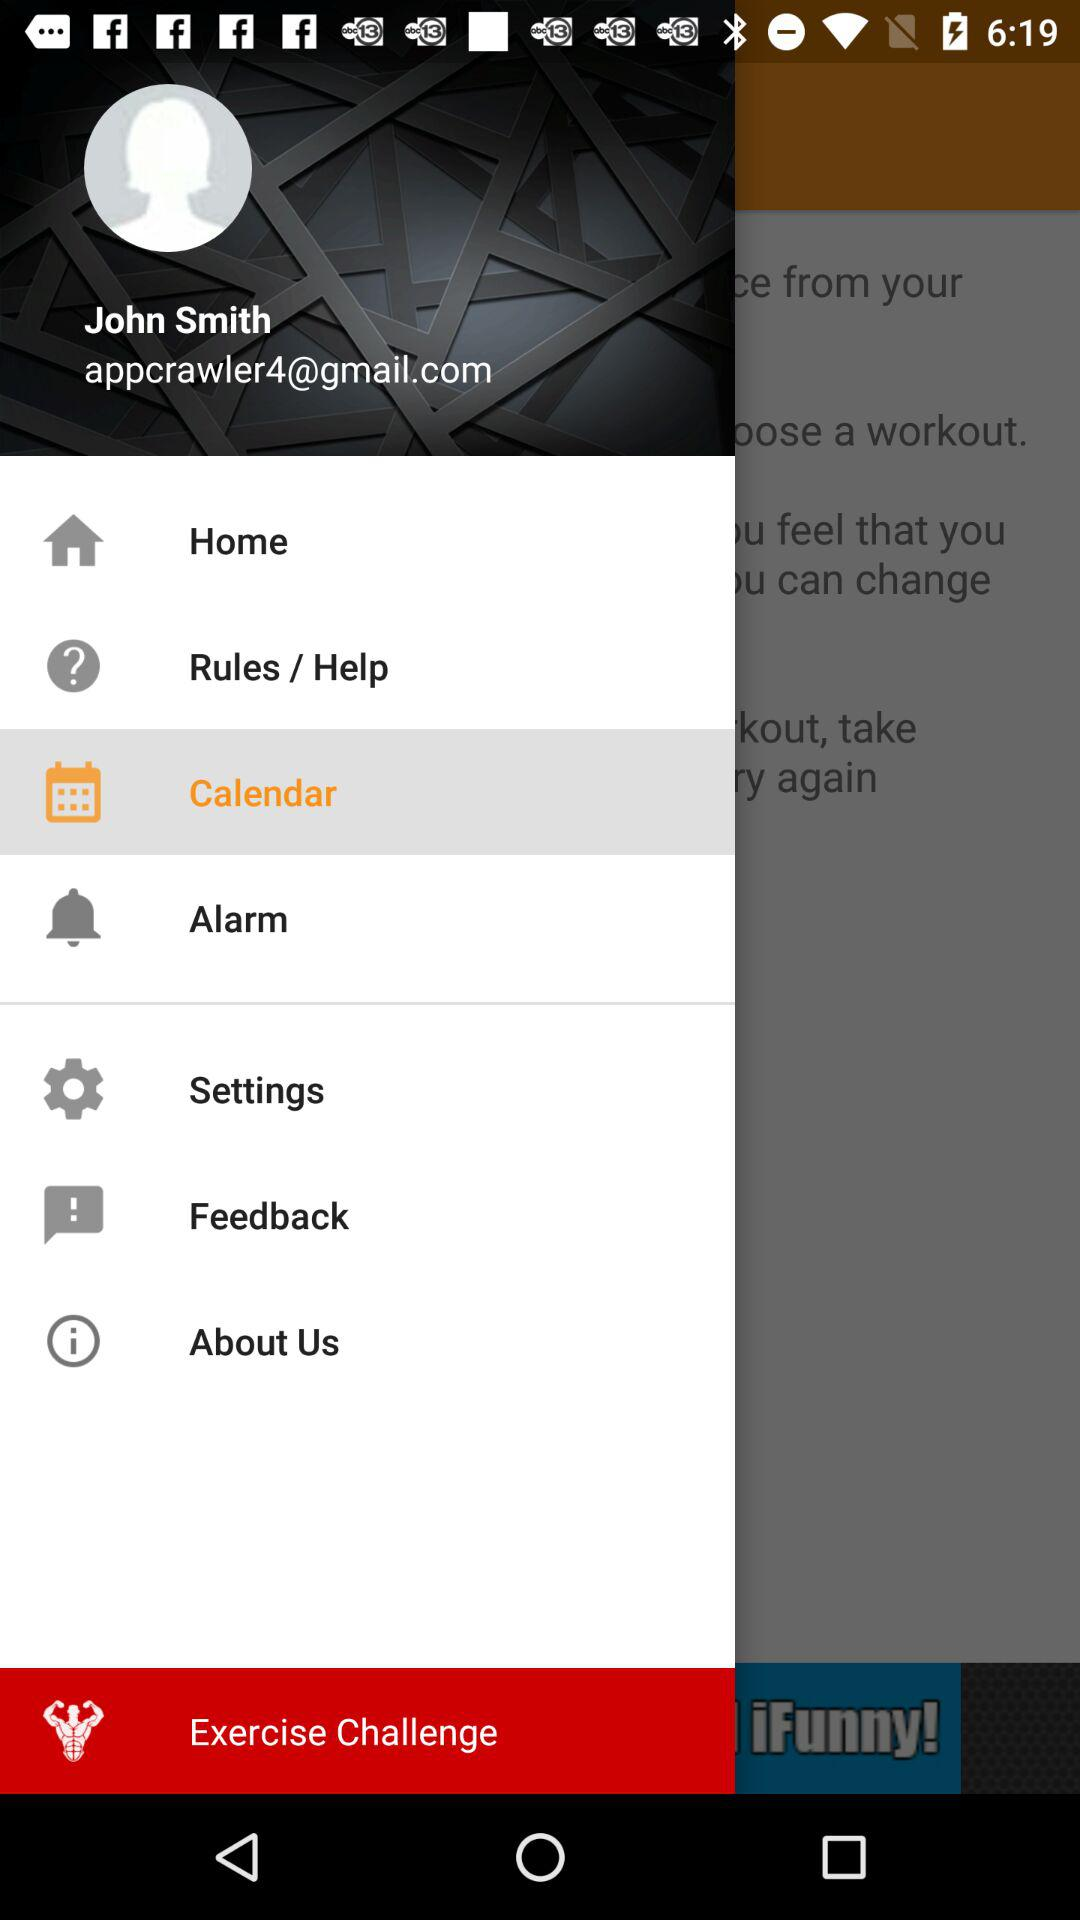Which item is selected in the menu? The selected item is "Calendar". 